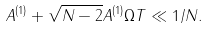Convert formula to latex. <formula><loc_0><loc_0><loc_500><loc_500>A ^ { ( 1 ) } + \sqrt { N - 2 } A ^ { ( 1 ) } \Omega T \ll 1 / N .</formula> 